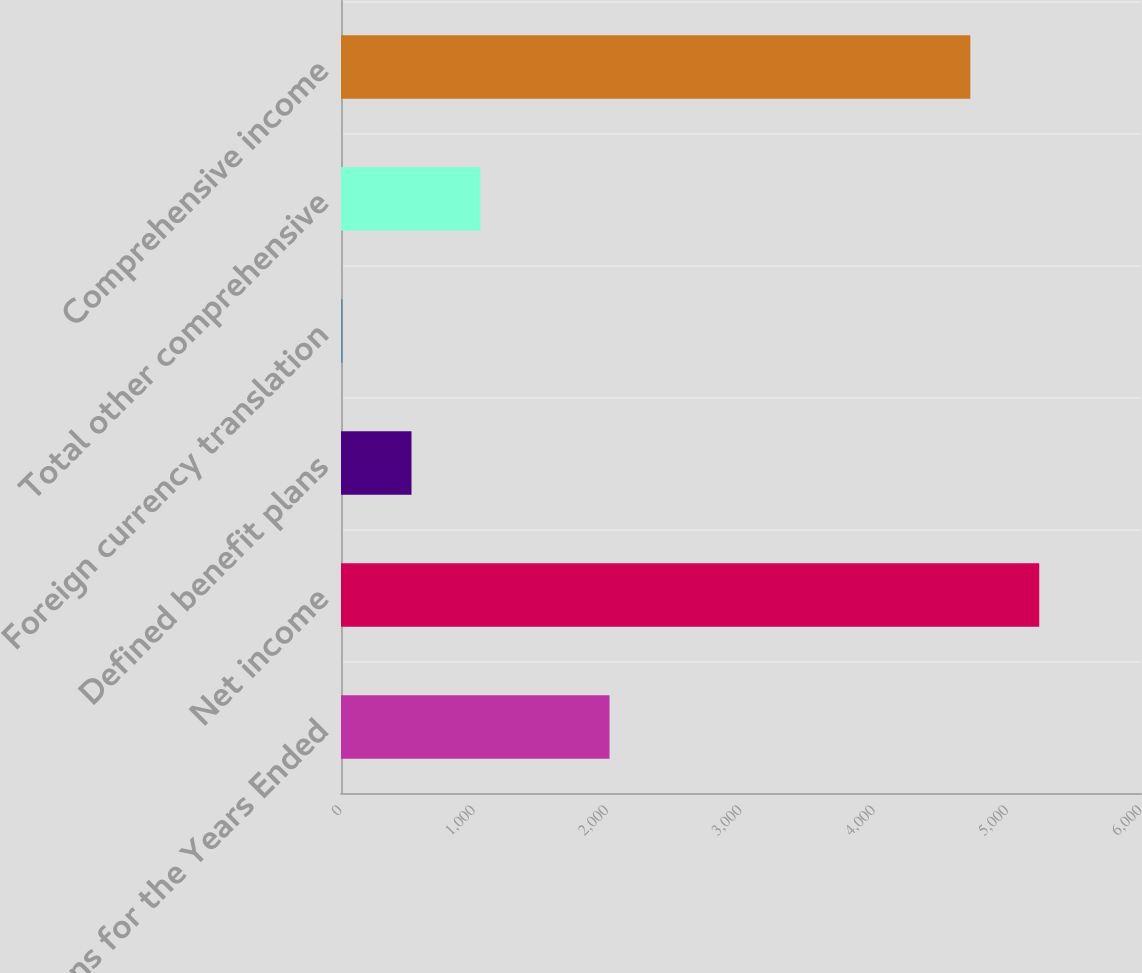Convert chart. <chart><loc_0><loc_0><loc_500><loc_500><bar_chart><fcel>Millions for the Years Ended<fcel>Net income<fcel>Defined benefit plans<fcel>Foreign currency translation<fcel>Total other comprehensive<fcel>Comprehensive income<nl><fcel>2014<fcel>5236.8<fcel>528.8<fcel>12<fcel>1045.6<fcel>4720<nl></chart> 